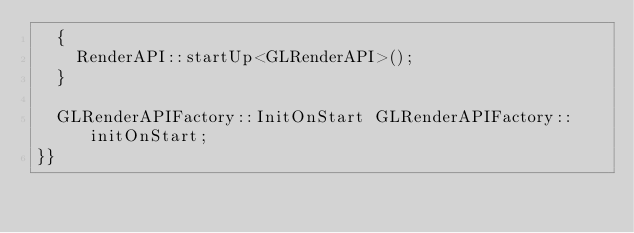<code> <loc_0><loc_0><loc_500><loc_500><_C++_>	{
		RenderAPI::startUp<GLRenderAPI>();
	}

	GLRenderAPIFactory::InitOnStart GLRenderAPIFactory::initOnStart;
}}
</code> 